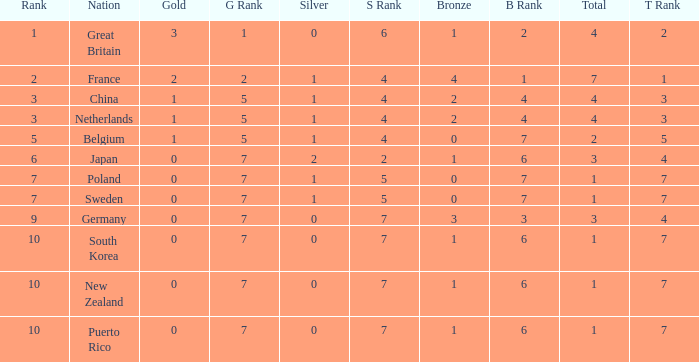What is the rank with 0 bronze? None. 